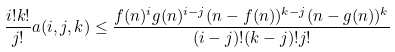Convert formula to latex. <formula><loc_0><loc_0><loc_500><loc_500>\frac { i ! k ! } { j ! } a ( i , j , k ) \leq \frac { f ( n ) ^ { i } g ( n ) ^ { i - j } ( n - f ( n ) ) ^ { k - j } ( n - g ( n ) ) ^ { k } } { ( i - j ) ! ( k - j ) ! j ! }</formula> 